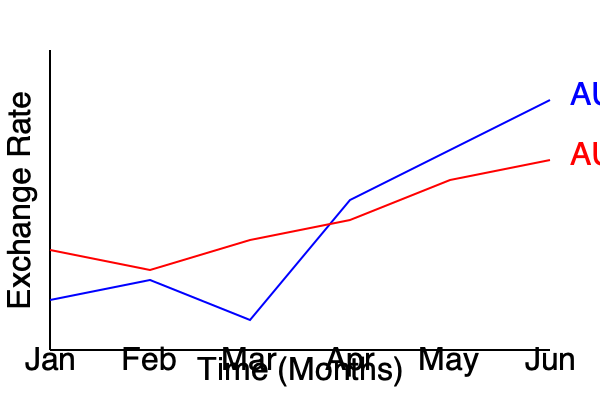As an importer, you're analyzing exchange rate trends for the Australian Dollar (AUD) against the US Dollar (USD) and Euro (EUR). Based on the graph, during which month would it have been most cost-effective to transfer AUD to USD for an import payment, and what strategy could you implement to potentially reduce future transfer costs? To answer this question, we need to analyze the exchange rate trends for AUD/USD and AUD/EUR:

1. Examine the AUD/USD trend (blue line):
   - The line shows a general upward trend, indicating the AUD is strengthening against the USD.
   - The lowest point (most favorable for buying USD) is in January.

2. Compare with AUD/EUR trend (red line):
   - The AUD/EUR rate shows less volatility but a slight downward trend.

3. Identify the most cost-effective month for AUD to USD transfer:
   - January has the lowest exchange rate, meaning you get more USD for your AUD.

4. Strategy to reduce future transfer costs:
   a) Monitor exchange rates regularly to identify favorable periods.
   b) Consider using forward contracts to lock in favorable rates.
   c) Explore multi-currency accounts to hold USD and EUR, allowing transfers when rates are favorable.
   d) Investigate lower-cost transfer services specializing in business foreign exchange.

5. Additional consideration:
   - The trend suggests the AUD is generally strengthening against the USD, so earlier transfers in the period would have been more cost-effective.
Answer: January; implement forward contracts and multi-currency accounts. 